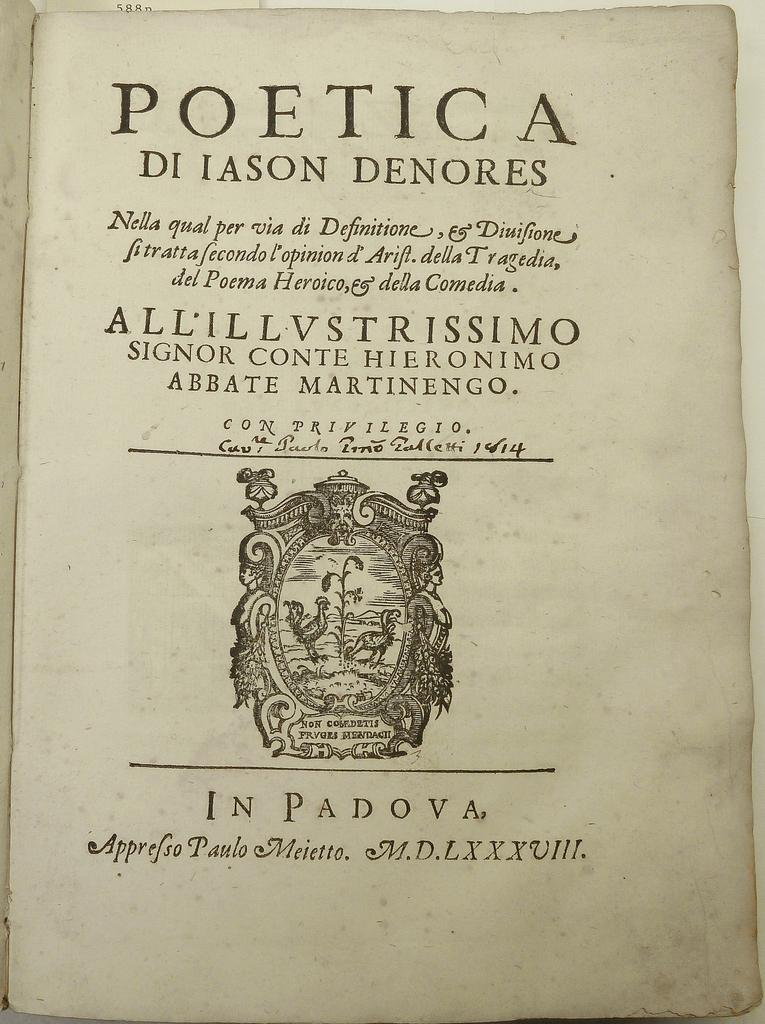<image>
Relay a brief, clear account of the picture shown. Book on a page with the word "Poetica" on the top and a symbol near the bottom. 